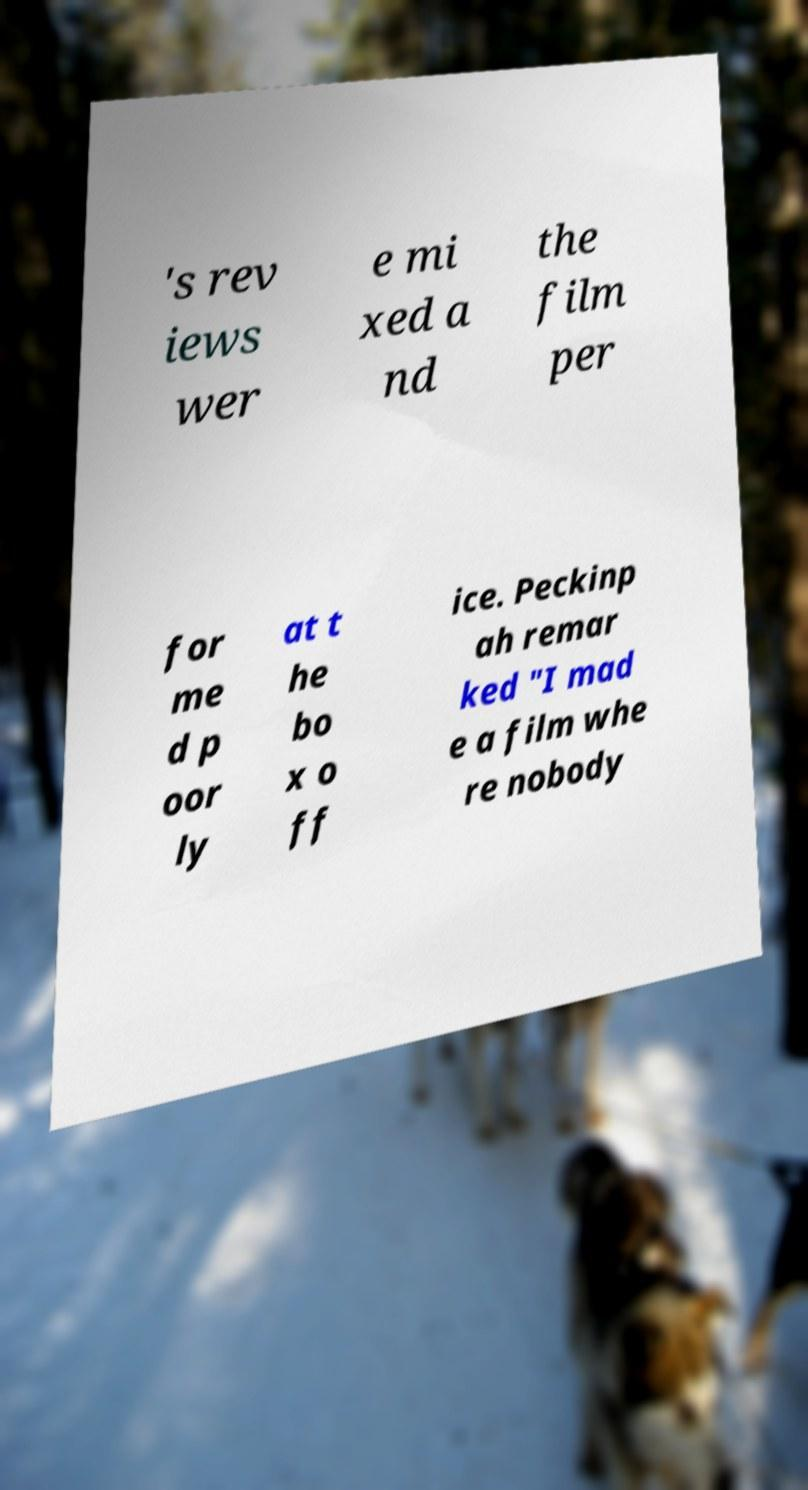Please read and relay the text visible in this image. What does it say? 's rev iews wer e mi xed a nd the film per for me d p oor ly at t he bo x o ff ice. Peckinp ah remar ked "I mad e a film whe re nobody 